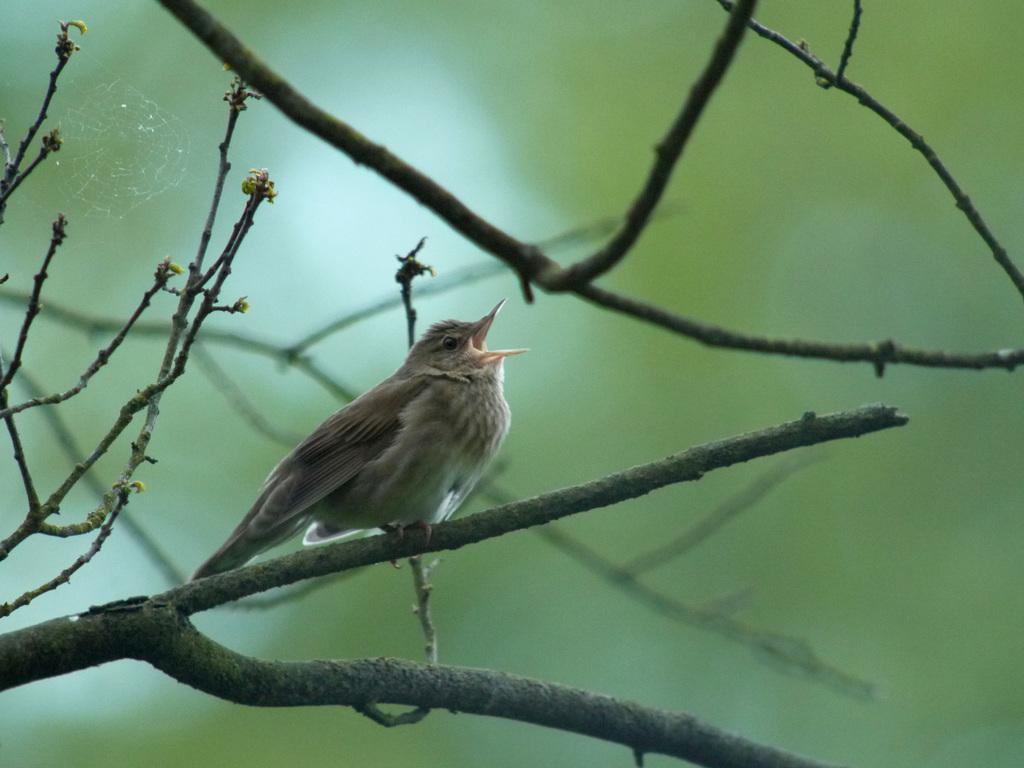What is the main subject in the center of the image? There is a bird in the center of the image. Where is the bird positioned in the image? The bird is on the stem stock. What else can be seen in the image besides the bird? There is a web in the image. What type of cloud can be seen in the image? There is no cloud present in the image; it features a bird on a stem stock with a web. What type of hook is attached to the bird in the image? There is no hook attached to the bird in the image. 